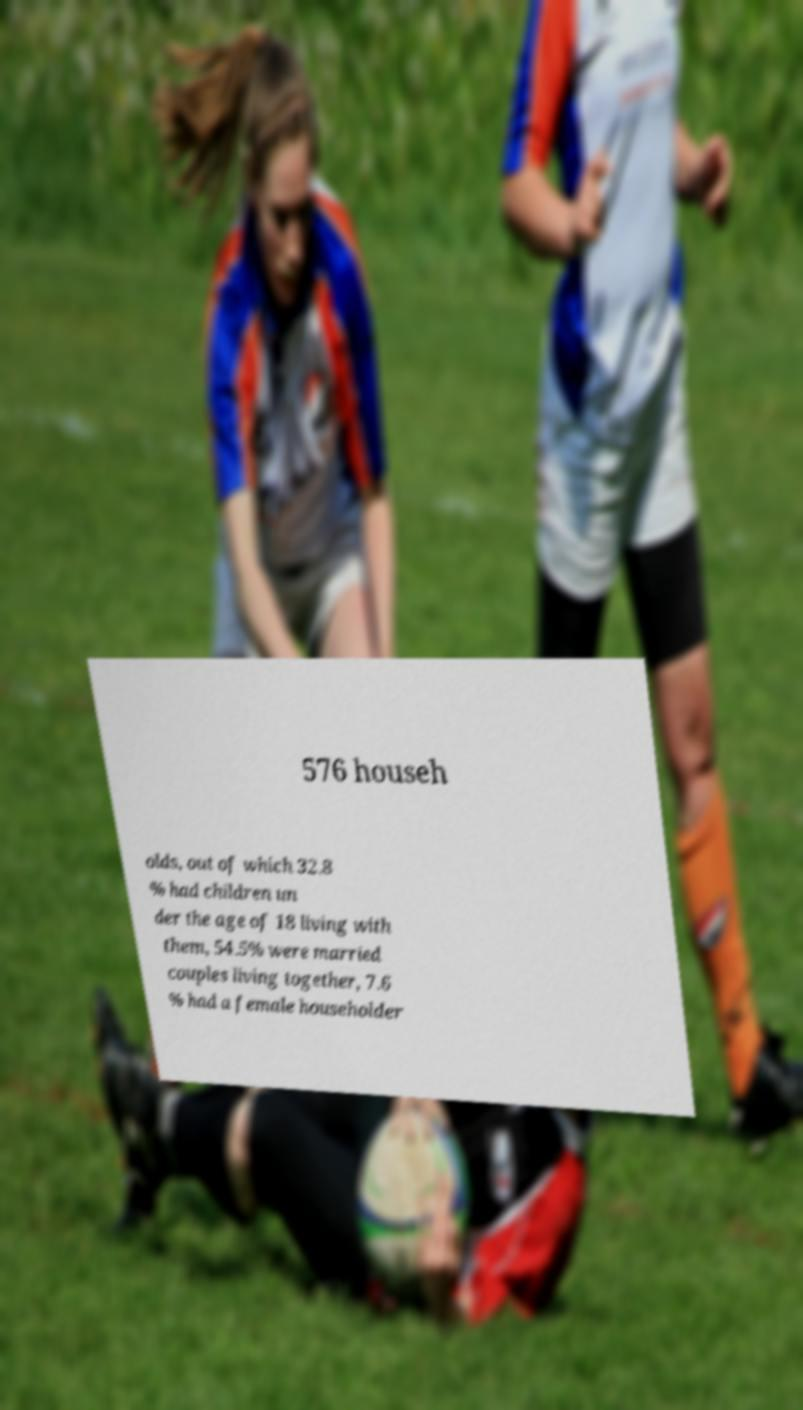Could you assist in decoding the text presented in this image and type it out clearly? 576 househ olds, out of which 32.8 % had children un der the age of 18 living with them, 54.5% were married couples living together, 7.6 % had a female householder 